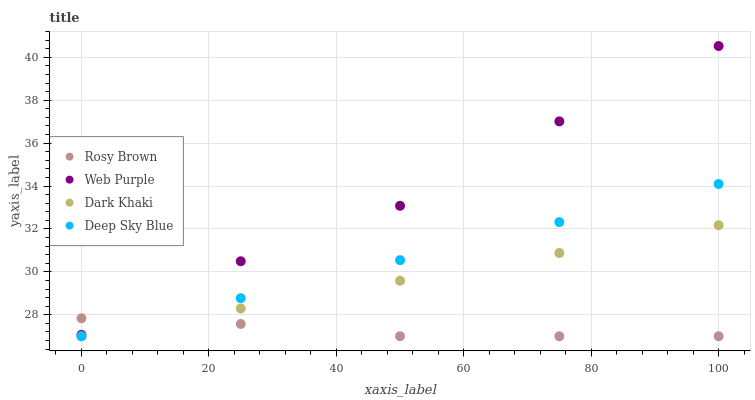Does Rosy Brown have the minimum area under the curve?
Answer yes or no. Yes. Does Web Purple have the maximum area under the curve?
Answer yes or no. Yes. Does Web Purple have the minimum area under the curve?
Answer yes or no. No. Does Rosy Brown have the maximum area under the curve?
Answer yes or no. No. Is Dark Khaki the smoothest?
Answer yes or no. Yes. Is Web Purple the roughest?
Answer yes or no. Yes. Is Rosy Brown the smoothest?
Answer yes or no. No. Is Rosy Brown the roughest?
Answer yes or no. No. Does Dark Khaki have the lowest value?
Answer yes or no. Yes. Does Web Purple have the lowest value?
Answer yes or no. No. Does Web Purple have the highest value?
Answer yes or no. Yes. Does Rosy Brown have the highest value?
Answer yes or no. No. Is Deep Sky Blue less than Web Purple?
Answer yes or no. Yes. Is Web Purple greater than Dark Khaki?
Answer yes or no. Yes. Does Deep Sky Blue intersect Rosy Brown?
Answer yes or no. Yes. Is Deep Sky Blue less than Rosy Brown?
Answer yes or no. No. Is Deep Sky Blue greater than Rosy Brown?
Answer yes or no. No. Does Deep Sky Blue intersect Web Purple?
Answer yes or no. No. 